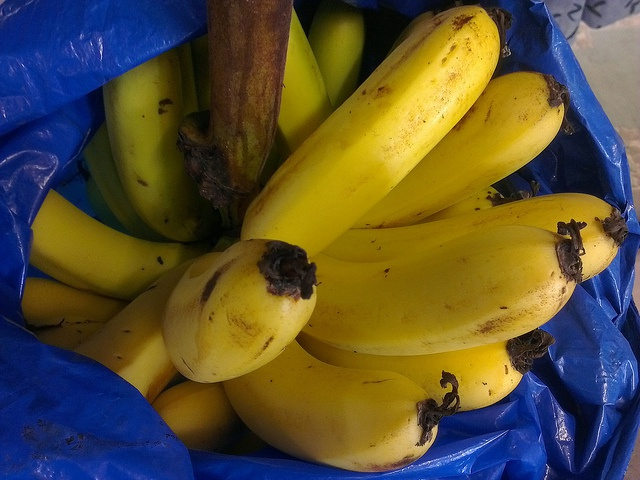Describe the objects in this image and their specific colors. I can see banana in gray, olive, and black tones and banana in gray, olive, and black tones in this image. 